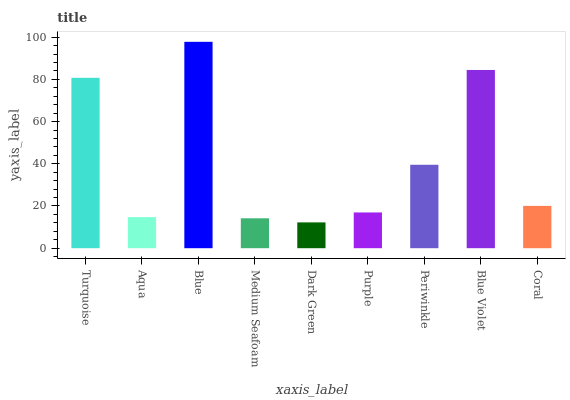Is Dark Green the minimum?
Answer yes or no. Yes. Is Blue the maximum?
Answer yes or no. Yes. Is Aqua the minimum?
Answer yes or no. No. Is Aqua the maximum?
Answer yes or no. No. Is Turquoise greater than Aqua?
Answer yes or no. Yes. Is Aqua less than Turquoise?
Answer yes or no. Yes. Is Aqua greater than Turquoise?
Answer yes or no. No. Is Turquoise less than Aqua?
Answer yes or no. No. Is Coral the high median?
Answer yes or no. Yes. Is Coral the low median?
Answer yes or no. Yes. Is Purple the high median?
Answer yes or no. No. Is Blue the low median?
Answer yes or no. No. 